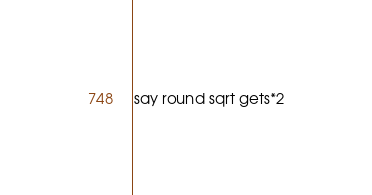Convert code to text. <code><loc_0><loc_0><loc_500><loc_500><_Perl_>say round sqrt gets*2</code> 